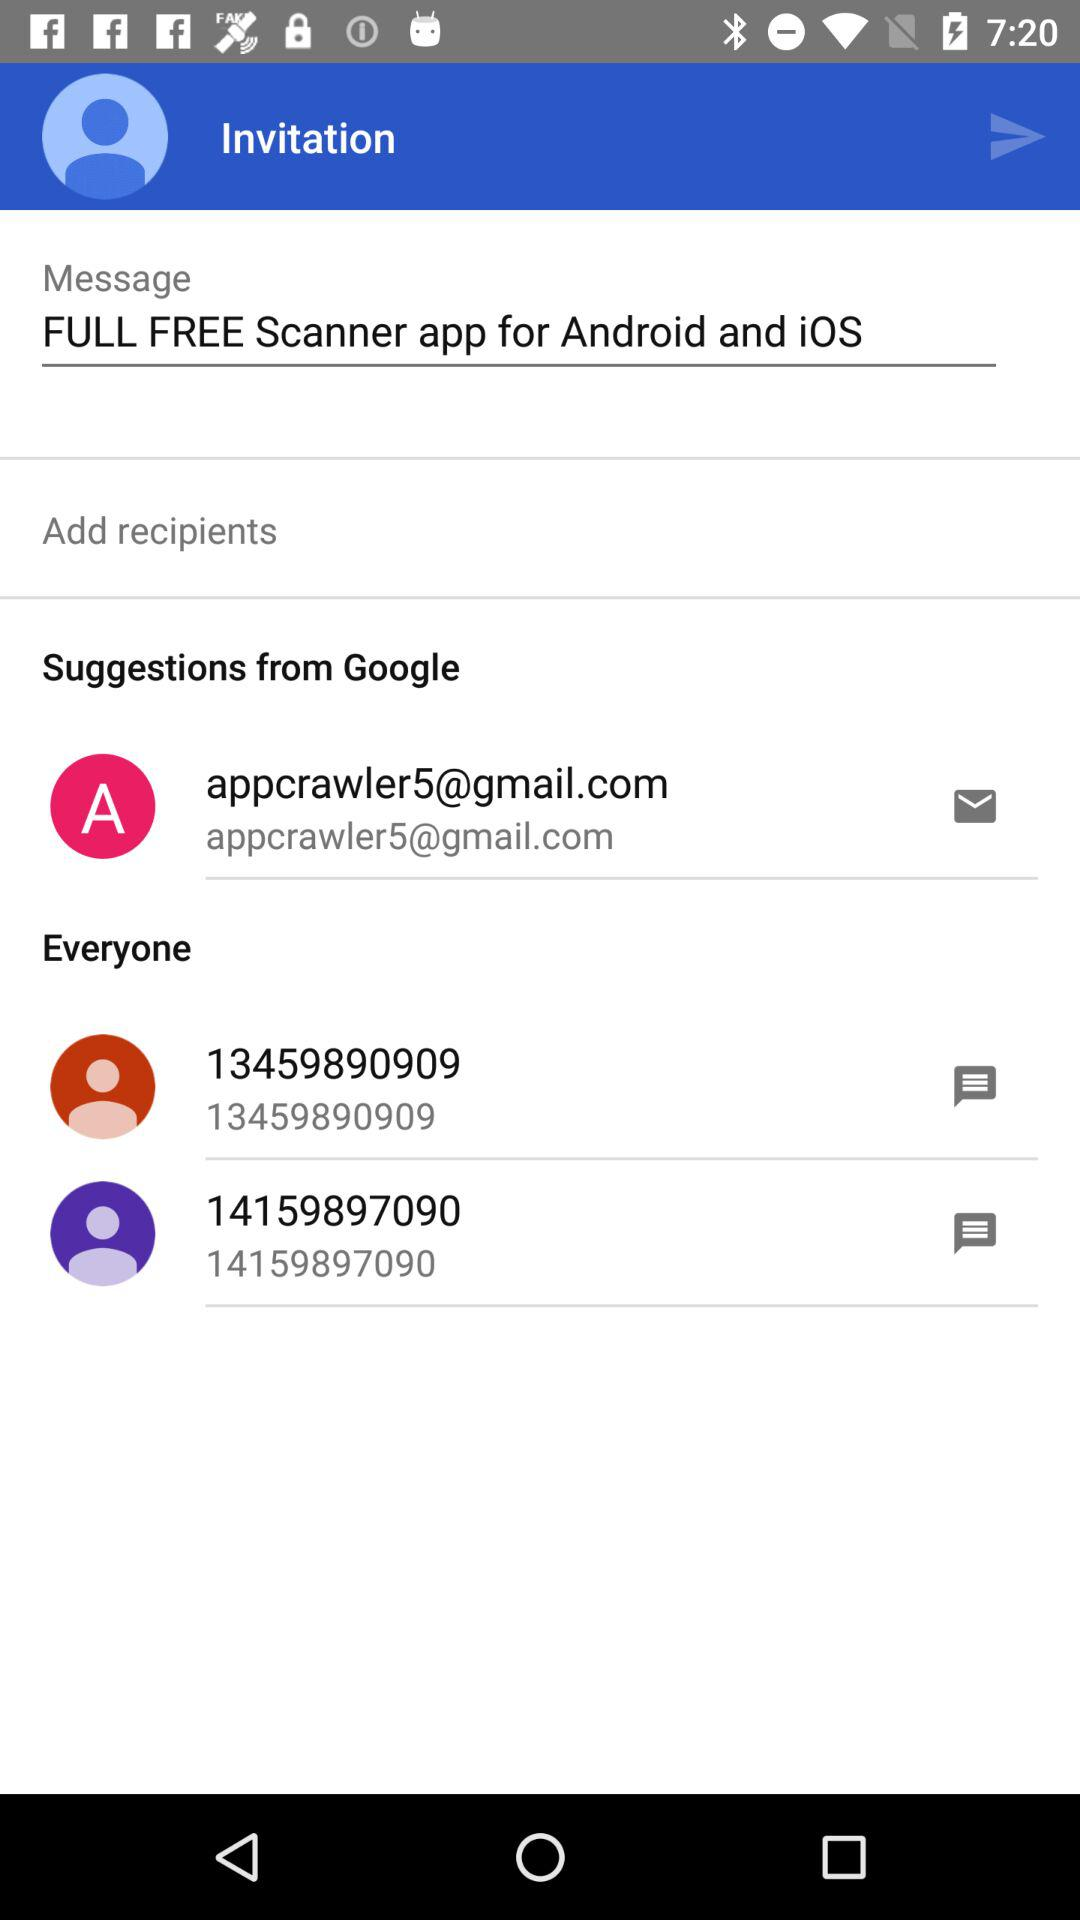What is written in the message? In the message, "FULL FREE Scanner app for Android and iOS" is written. 